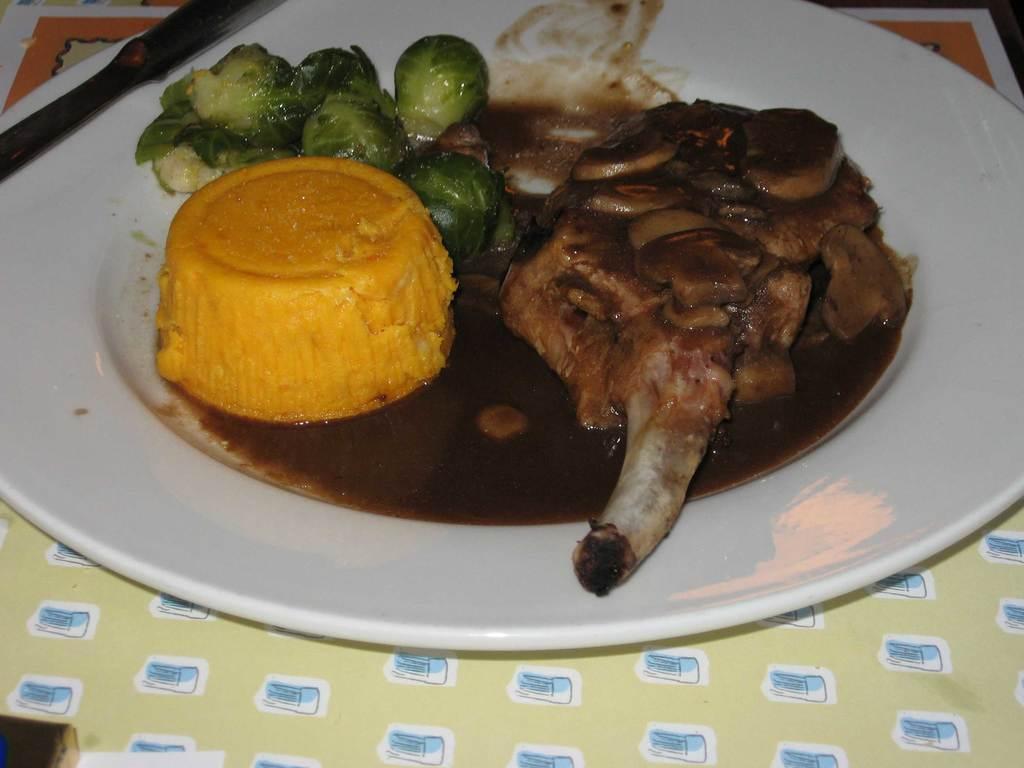Please provide a concise description of this image. In this image there are food items in a plate which was placed on the table. 